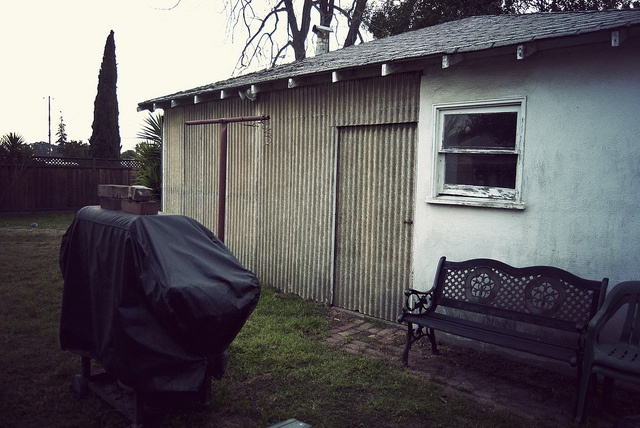Describe the objects in this image and their specific colors. I can see bench in ivory, black, gray, and darkgray tones and chair in ivory, black, and purple tones in this image. 